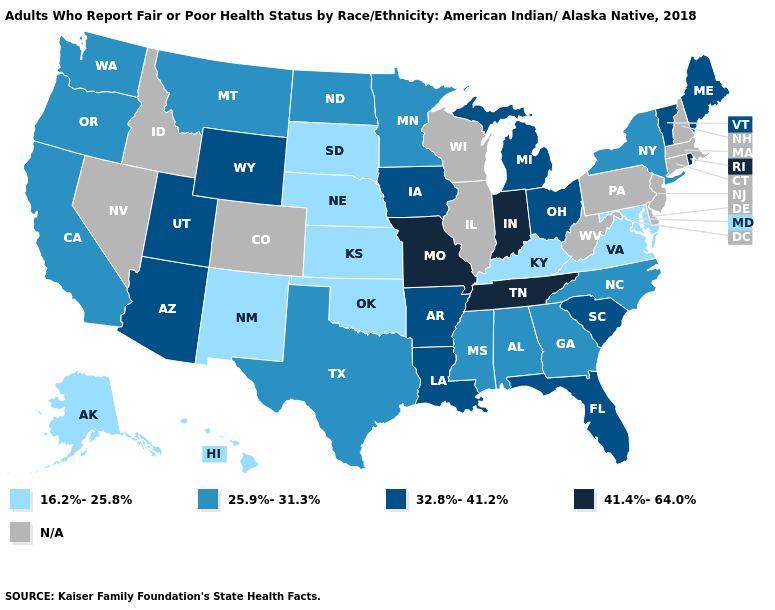Which states hav the highest value in the Northeast?
Give a very brief answer. Rhode Island. Name the states that have a value in the range 25.9%-31.3%?
Concise answer only. Alabama, California, Georgia, Minnesota, Mississippi, Montana, New York, North Carolina, North Dakota, Oregon, Texas, Washington. Name the states that have a value in the range 41.4%-64.0%?
Short answer required. Indiana, Missouri, Rhode Island, Tennessee. Among the states that border West Virginia , which have the lowest value?
Write a very short answer. Kentucky, Maryland, Virginia. What is the lowest value in the USA?
Write a very short answer. 16.2%-25.8%. What is the value of Illinois?
Answer briefly. N/A. Name the states that have a value in the range 41.4%-64.0%?
Concise answer only. Indiana, Missouri, Rhode Island, Tennessee. Name the states that have a value in the range N/A?
Concise answer only. Colorado, Connecticut, Delaware, Idaho, Illinois, Massachusetts, Nevada, New Hampshire, New Jersey, Pennsylvania, West Virginia, Wisconsin. Name the states that have a value in the range 16.2%-25.8%?
Short answer required. Alaska, Hawaii, Kansas, Kentucky, Maryland, Nebraska, New Mexico, Oklahoma, South Dakota, Virginia. Name the states that have a value in the range 32.8%-41.2%?
Quick response, please. Arizona, Arkansas, Florida, Iowa, Louisiana, Maine, Michigan, Ohio, South Carolina, Utah, Vermont, Wyoming. What is the highest value in the West ?
Be succinct. 32.8%-41.2%. What is the value of Michigan?
Write a very short answer. 32.8%-41.2%. Which states hav the highest value in the West?
Concise answer only. Arizona, Utah, Wyoming. Name the states that have a value in the range 16.2%-25.8%?
Short answer required. Alaska, Hawaii, Kansas, Kentucky, Maryland, Nebraska, New Mexico, Oklahoma, South Dakota, Virginia. Name the states that have a value in the range 25.9%-31.3%?
Write a very short answer. Alabama, California, Georgia, Minnesota, Mississippi, Montana, New York, North Carolina, North Dakota, Oregon, Texas, Washington. 